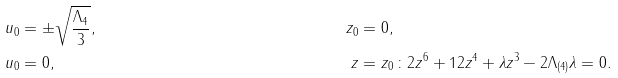<formula> <loc_0><loc_0><loc_500><loc_500>u _ { 0 } & = \pm \sqrt { \frac { \Lambda _ { 4 } } { 3 } } , & z _ { 0 } & = 0 , \\ u _ { 0 } & = 0 , & z & = z _ { 0 } \, \colon 2 z ^ { 6 } + 1 2 z ^ { 4 } + \lambda z ^ { 3 } - 2 \Lambda _ { ( 4 ) } \lambda = 0 .</formula> 